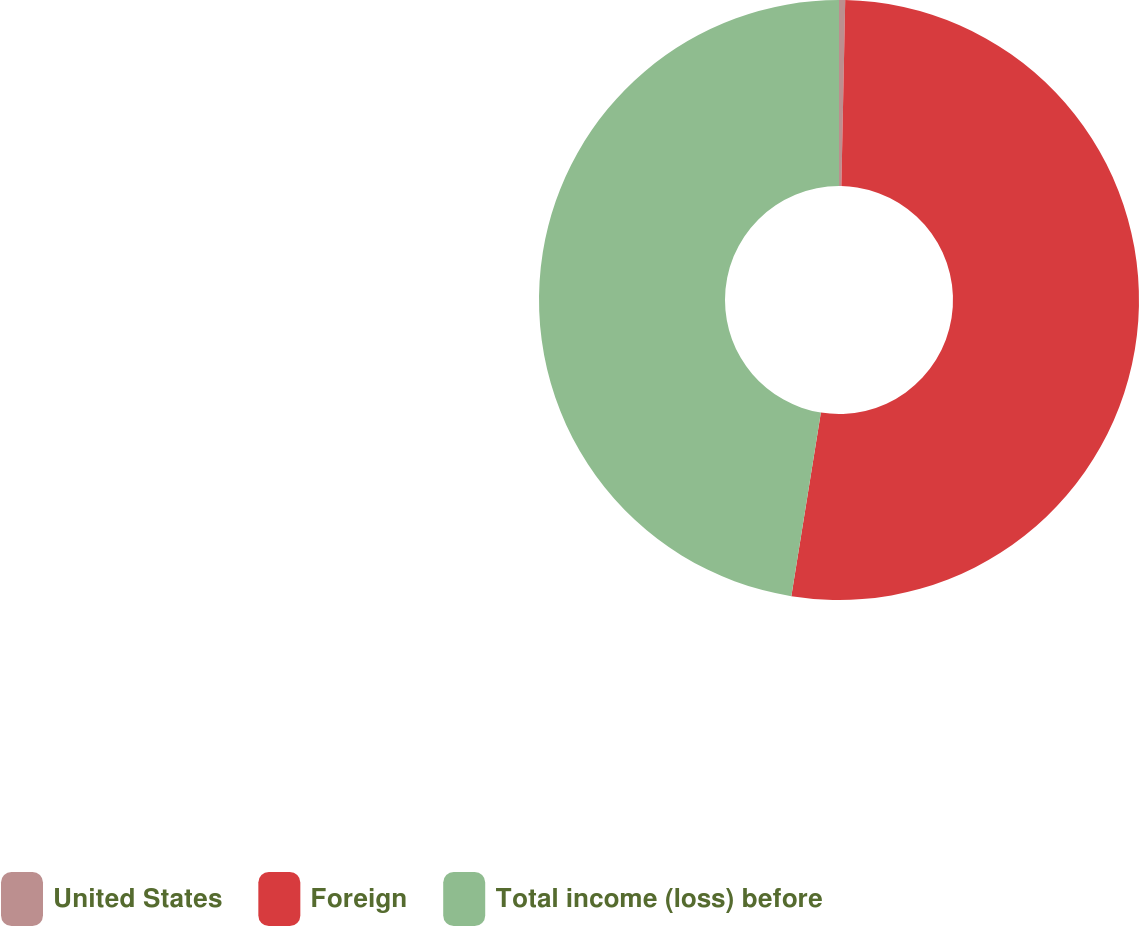<chart> <loc_0><loc_0><loc_500><loc_500><pie_chart><fcel>United States<fcel>Foreign<fcel>Total income (loss) before<nl><fcel>0.33%<fcel>52.21%<fcel>47.46%<nl></chart> 